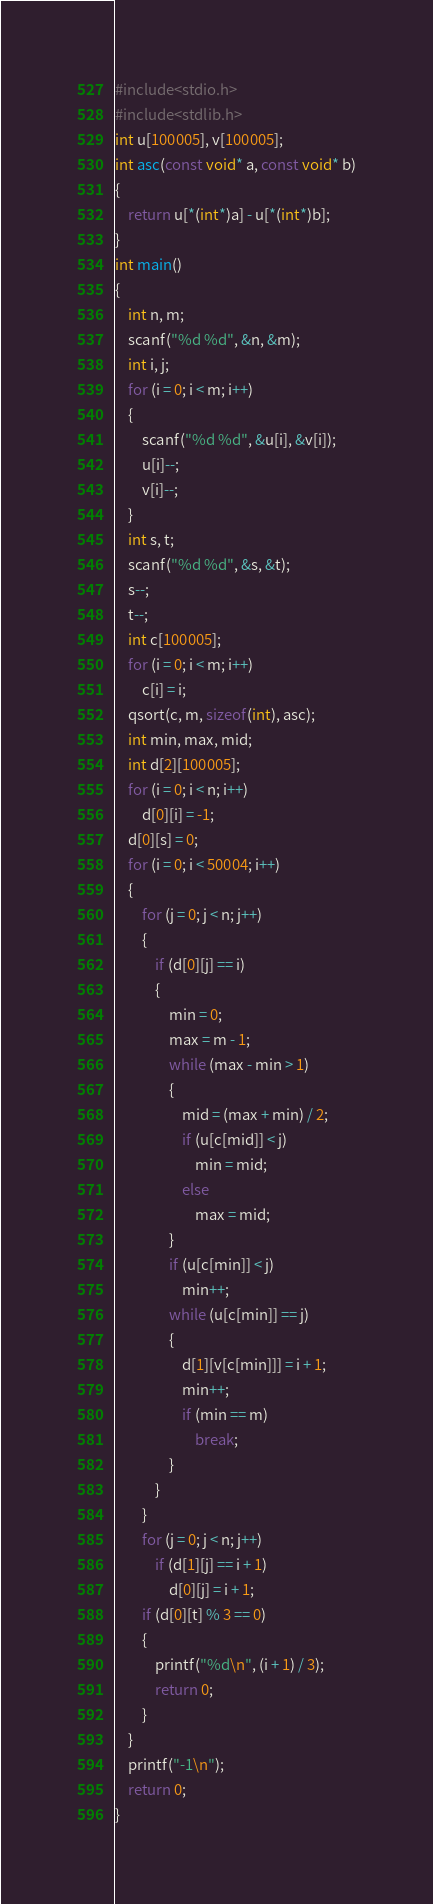<code> <loc_0><loc_0><loc_500><loc_500><_C_>#include<stdio.h>
#include<stdlib.h>
int u[100005], v[100005];
int asc(const void* a, const void* b)
{
	return u[*(int*)a] - u[*(int*)b];
}
int main()
{
	int n, m;
	scanf("%d %d", &n, &m);
	int i, j;
	for (i = 0; i < m; i++)
	{
		scanf("%d %d", &u[i], &v[i]);
		u[i]--;
		v[i]--;
	}
	int s, t;
	scanf("%d %d", &s, &t);
	s--;
	t--;
	int c[100005];
	for (i = 0; i < m; i++)
		c[i] = i;
	qsort(c, m, sizeof(int), asc);
	int min, max, mid;
	int d[2][100005];
	for (i = 0; i < n; i++)
		d[0][i] = -1;
	d[0][s] = 0;
	for (i = 0; i < 50004; i++)
	{
		for (j = 0; j < n; j++)
		{
			if (d[0][j] == i)
			{
				min = 0;
				max = m - 1;
				while (max - min > 1)
				{
					mid = (max + min) / 2;
					if (u[c[mid]] < j)
						min = mid;
					else
						max = mid;
				}
				if (u[c[min]] < j)
					min++;
				while (u[c[min]] == j)
				{
					d[1][v[c[min]]] = i + 1;
					min++;
					if (min == m)
						break;
				}
			}
		}
		for (j = 0; j < n; j++)
			if (d[1][j] == i + 1)
				d[0][j] = i + 1;
		if (d[0][t] % 3 == 0)
		{
			printf("%d\n", (i + 1) / 3);
			return 0;
		}
	}
	printf("-1\n");
	return 0;
}</code> 